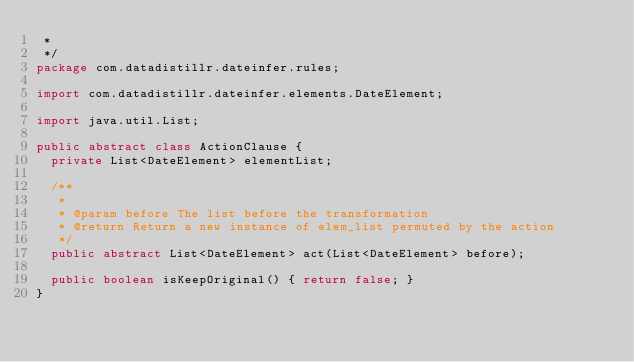Convert code to text. <code><loc_0><loc_0><loc_500><loc_500><_Java_> *
 */
package com.datadistillr.dateinfer.rules;

import com.datadistillr.dateinfer.elements.DateElement;

import java.util.List;

public abstract class ActionClause {
  private List<DateElement> elementList;

  /**
   *
   * @param before The list before the transformation
   * @return Return a new instance of elem_list permuted by the action
   */
  public abstract List<DateElement> act(List<DateElement> before);

  public boolean isKeepOriginal() { return false; }
}
</code> 